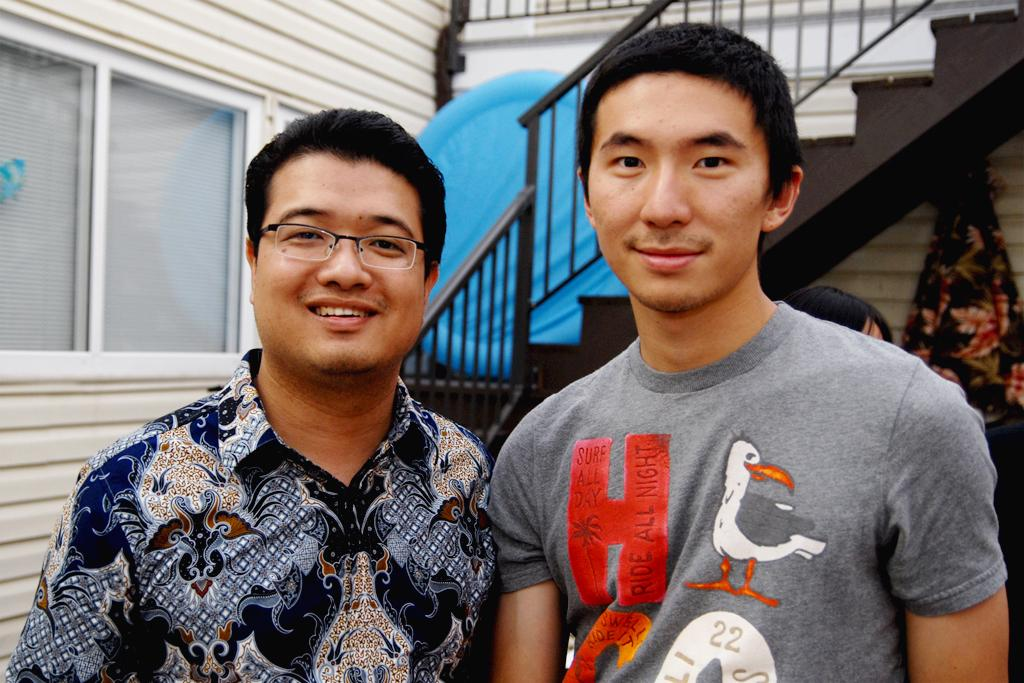What can be seen in the image involving people? There are people standing in the image. What type of structure is present in the image? There is a building with windows in the image. What architectural feature is visible in the image? There is a staircase in the image. What object can be seen in the image that is made of cloth? There is a cloth in the image. Where is the park located in the image? There is no park present in the image. What type of jar can be seen on the staircase in the image? There is no jar present in the image. 